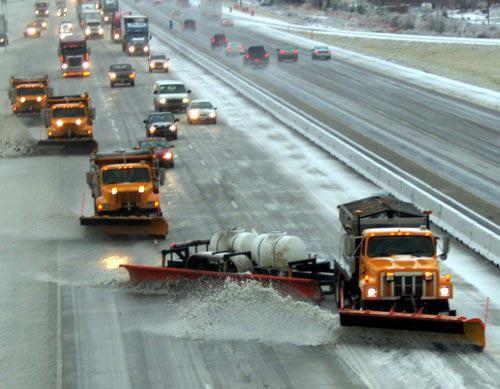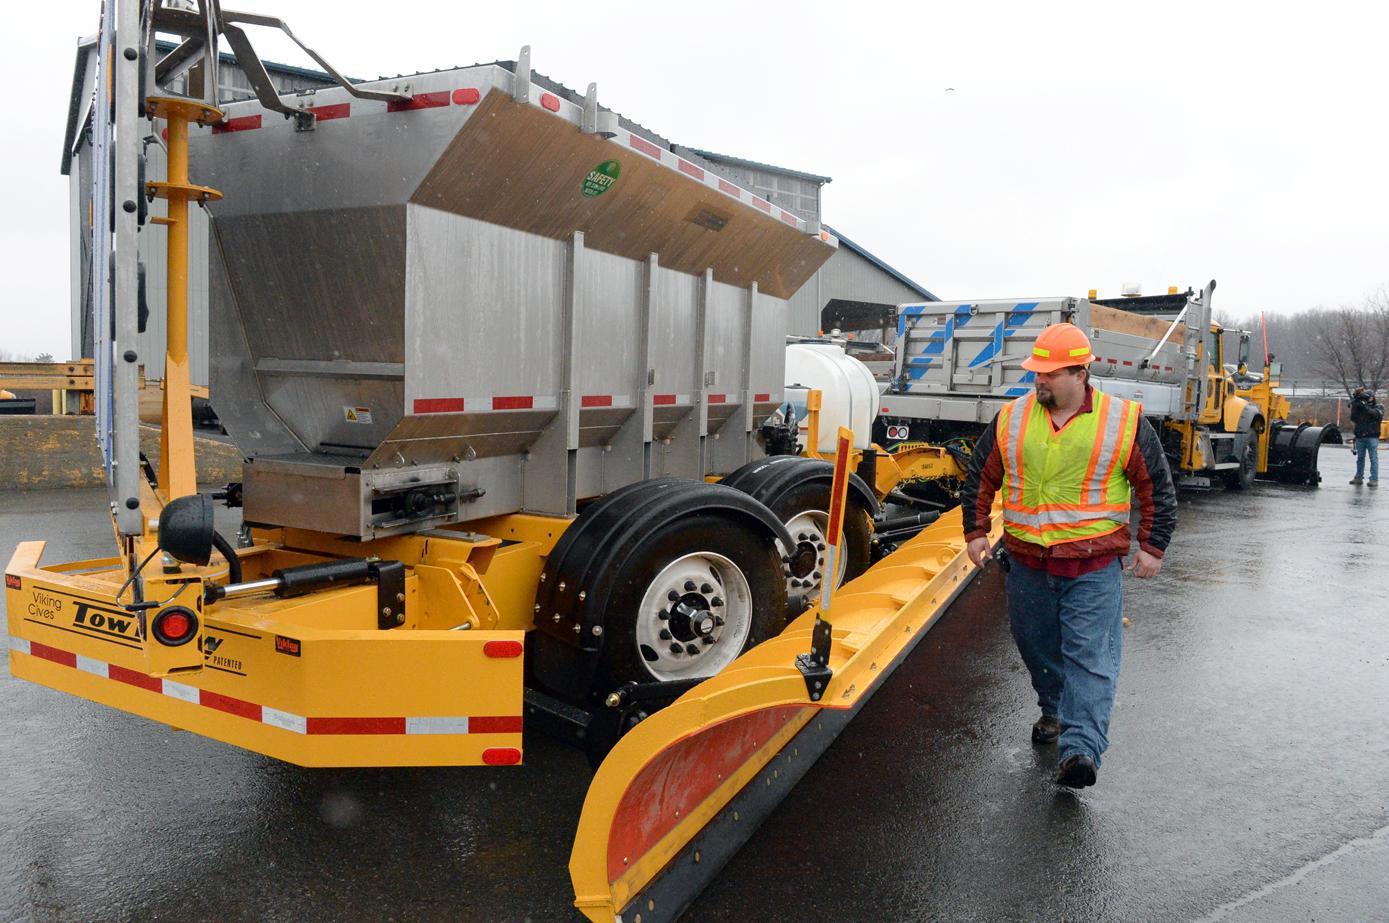The first image is the image on the left, the second image is the image on the right. Given the left and right images, does the statement "A bulldozers front panel is partially lifted off the ground." hold true? Answer yes or no. No. 